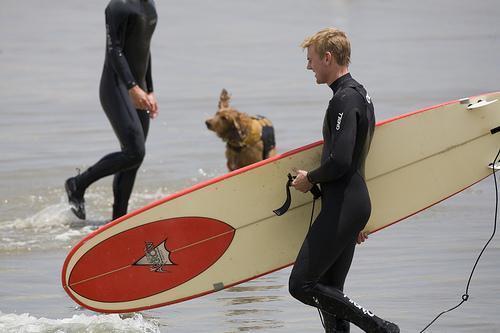How many of the dogs ears are raised?
Give a very brief answer. 1. How many people are to the left of the dog?
Give a very brief answer. 1. 